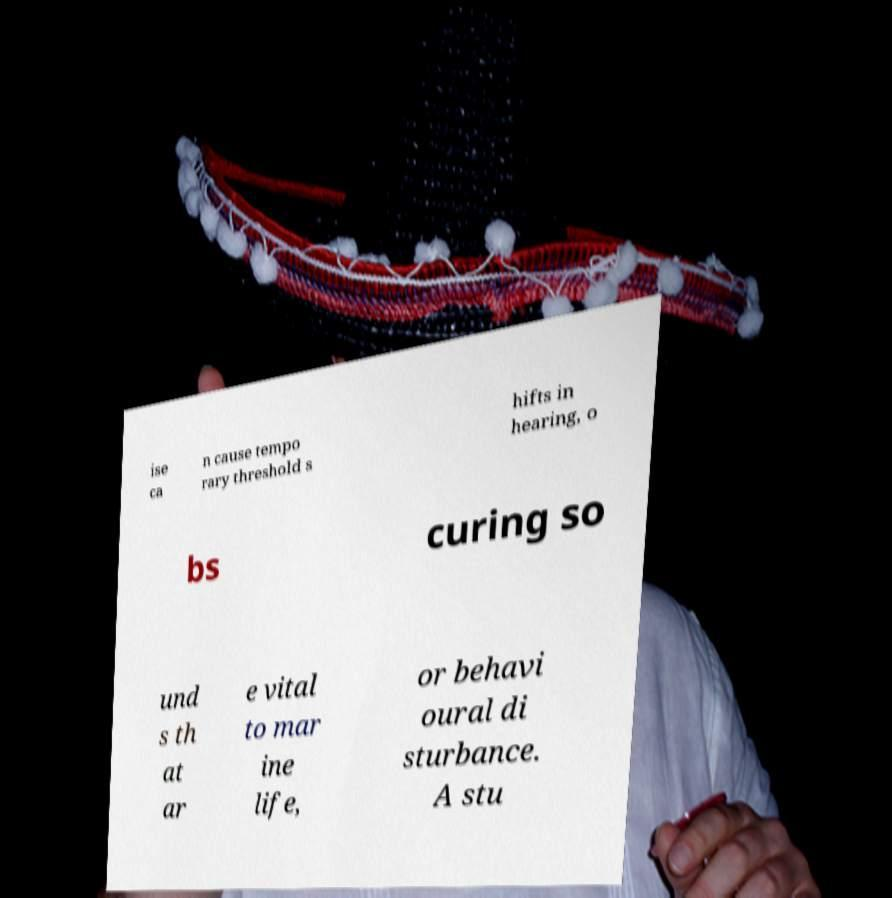What messages or text are displayed in this image? I need them in a readable, typed format. ise ca n cause tempo rary threshold s hifts in hearing, o bs curing so und s th at ar e vital to mar ine life, or behavi oural di sturbance. A stu 